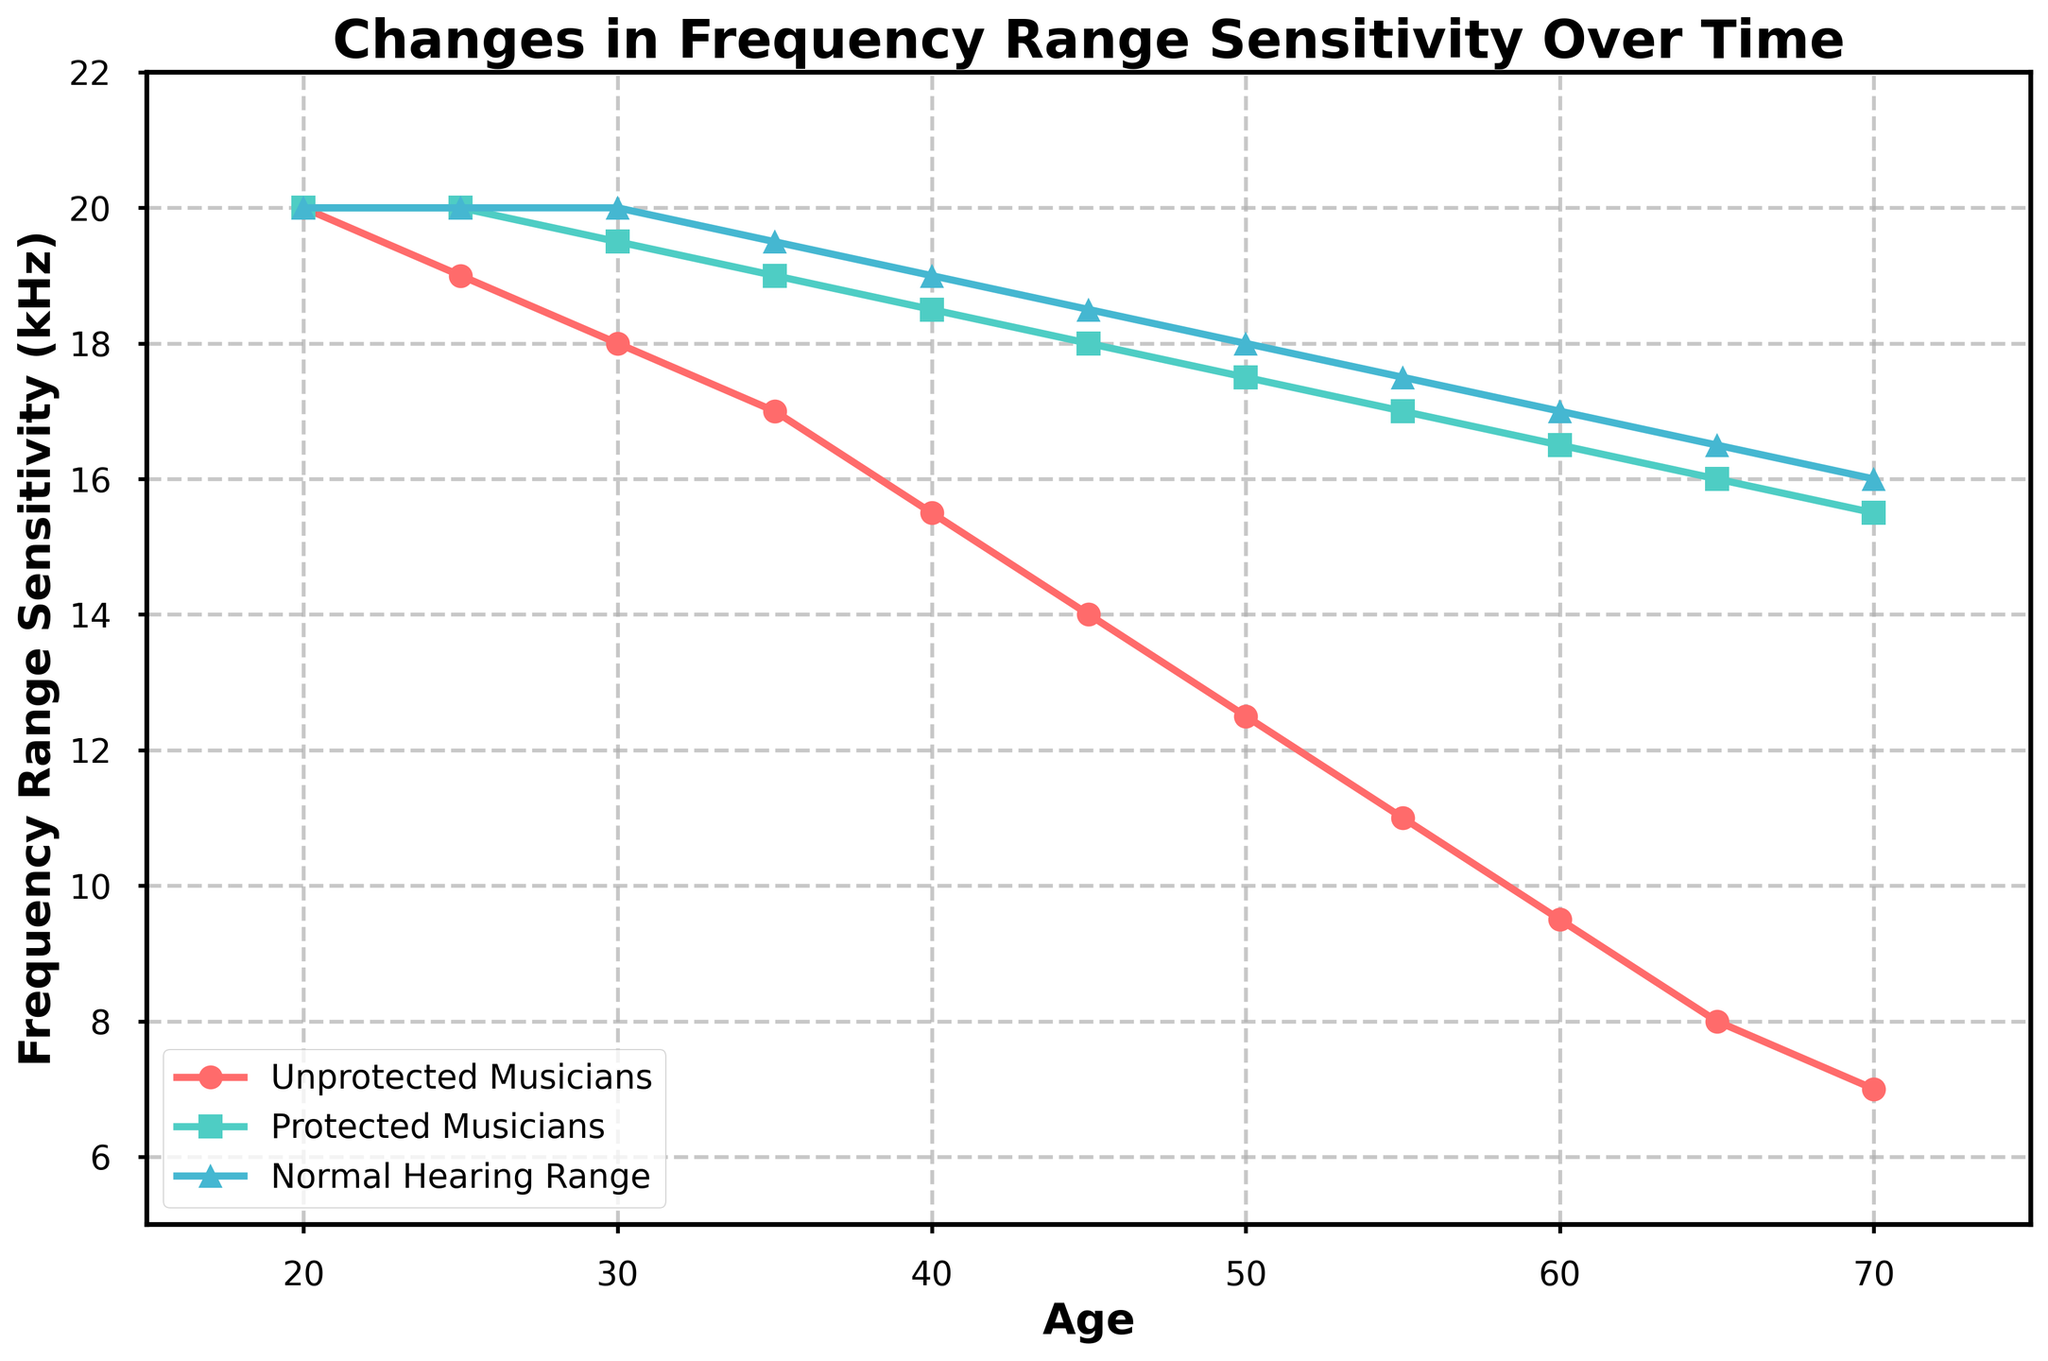What is the frequency range sensitivity of Unprotected Musicians at age 40? Locate age 40 on the x-axis, trace vertically to the red line (Unprotected Musicians), read the y-axis value which is 15.5 kHz
Answer: 15.5 kHz At what age does the frequency range sensitivity of Protected Musicians fall to 17.5 kHz? Find the green line representing Protected Musicians, trace until it intersects with 17.5 kHz on the y-axis, then look down to find the corresponding age on the x-axis, which is 50
Answer: 50 What is the average frequency range sensitivity of Unprotected Musicians and Protected Musicians at age 35? Locate age 35 on the x-axis, trace vertically to intersect both lines; Unprotected Musicians are at 17 kHz and Protected Musicians are at 19 kHz. Calculate the average: (17+19) / 2 = 18 kHz
Answer: 18 kHz How much more is the frequency range sensitivity of Protected Musicians compared to Unprotected Musicians at age 55? Locate age 55 on the x-axis and trace to both lines; Unprotected Musicians are at 11 kHz and Protected Musicians are at 17 kHz. Calculate the difference: 17 - 11 = 6 kHz
Answer: 6 kHz At what age does the sensitivity of Unprotected Musicians drop below 10 kHz? Trace the red line down to find where it falls below 10 kHz, it happens between ages 55 and 60. At age 60, it is 9.5 kHz, so it drops below 10 kHz around age 60
Answer: 60 Identify the age range where the frequency sensitivity of Protected Musicians stays above that of the Normal Hearing Range. Trace the green and blue lines, from age 25 to 70, the green line (Protected Musicians) is always above the blue line (Normal Hearing Range)
Answer: 25 to 70 Compare the trend lines: at what age does the frequency sensitivity of Protected Musicians match that of Normal Hearing Range, and what are those values? Look for the intersection of the green and blue lines, it happens at age 35, both having frequency range sensitivity of 19.5 kHz
Answer: 35, 19.5 kHz What is the total decline in frequency range sensitivity for Unprotected Musicians from age 20 to age 70? Find the values at age 20 (20 kHz) and 70 (7 kHz) for Unprotected Musicians; the decline is 20 - 7 = 13 kHz
Answer: 13 kHz At age 25, does the frequency sensitivity of Protected Musicians deviate from the Normal Hearing Range, and if so, by how much? Locate age 25 on the x-axis and compare the green line (20 kHz for Protected Musicians) with the blue line (20 kHz for Normal Hearing Range); there is no deviation
Answer: 0 kHz How does the frequency range sensitivity change for Protected Musicians from age 20 to 45? From the plot, find values at age 20 (20 kHz) and 45 (18 kHz), calculate the change: 18 - 20 = -2 kHz
Answer: -2 kHz 